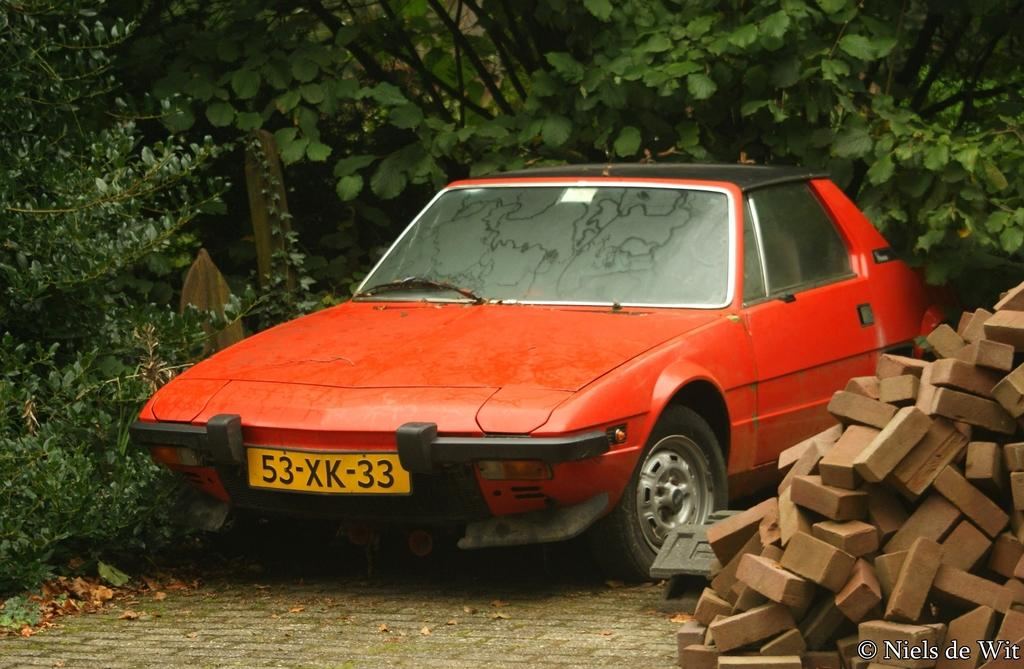What is the main subject of the image? There is a car in the image. Can you describe any specific features of the car? The car has a number plate. What can be seen on the right side of the image? There are bricks on the right side of the image. What is visible in the background of the image? There are trees visible in the background of the image. Is there any additional information or marking in the image? Yes, there is a watermark in the right bottom corner of the image. Can you tell me how many owls are sitting on the cactus in the image? There are no owls or cactus present in the image; it features a car with bricks on the right side and trees in the background. 